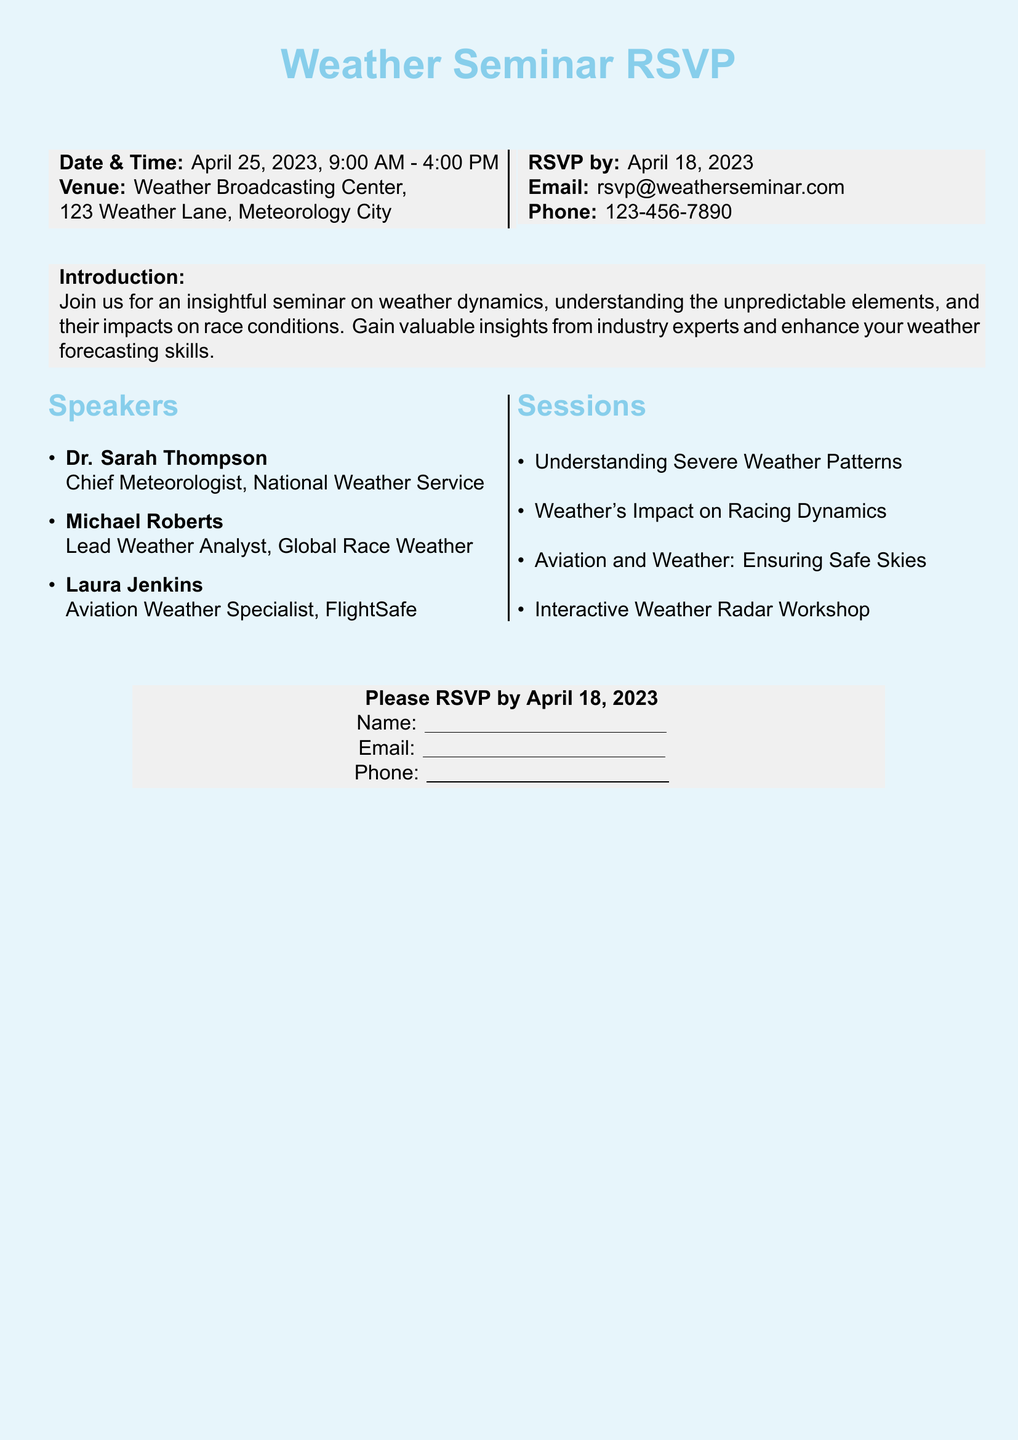What is the date of the seminar? The date of the seminar is clearly stated in the document as April 25, 2023.
Answer: April 25, 2023 Who is the Chief Meteorologist? The document lists Dr. Sarah Thompson as the Chief Meteorologist under the speakers section.
Answer: Dr. Sarah Thompson What is the venue for the seminar? The venue is mentioned in the document as the Weather Broadcasting Center, located at 123 Weather Lane, Meteorology City.
Answer: Weather Broadcasting Center When is the RSVP deadline? The RSVP deadline is specified in the document as April 18, 2023.
Answer: April 18, 2023 What type of workshop is included in the sessions? The sessions include an Interactive Weather Radar Workshop as listed in the sessions section.
Answer: Interactive Weather Radar Workshop Which speaker specializes in aviation weather? The document identifies Laura Jenkins as the Aviation Weather Specialist among the speakers.
Answer: Laura Jenkins How many sessions are listed in the document? The document enumerates four sessions in total under the sessions section.
Answer: Four What is the purpose of the seminar? The introduction states that the seminar aims to provide insights on weather dynamics and impacts on race conditions.
Answer: Gain valuable insights What contact method is provided for RSVP? The document provides an email address as the primary method for RSVP.
Answer: rsvp@weatherseminar.com What time does the seminar start? The document specifies the start time of the seminar as 9:00 AM.
Answer: 9:00 AM 